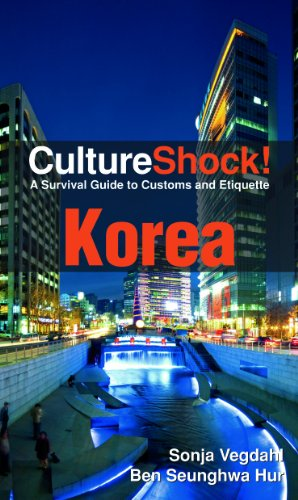What is the title of this book? The title of the book displayed in the image is 'CultureShock! Korea: A Survival Guide to Customs and Etiquette', a comprehensive guide aimed at aiding travelers understand and adapt to Korean culture. 